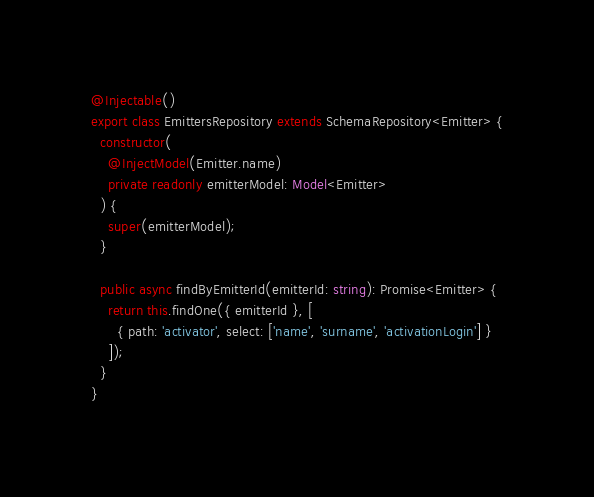<code> <loc_0><loc_0><loc_500><loc_500><_TypeScript_>@Injectable()
export class EmittersRepository extends SchemaRepository<Emitter> {
  constructor(
    @InjectModel(Emitter.name)
    private readonly emitterModel: Model<Emitter>
  ) {
    super(emitterModel);
  }

  public async findByEmitterId(emitterId: string): Promise<Emitter> {
    return this.findOne({ emitterId }, [
      { path: 'activator', select: ['name', 'surname', 'activationLogin'] }
    ]);
  }
}
</code> 